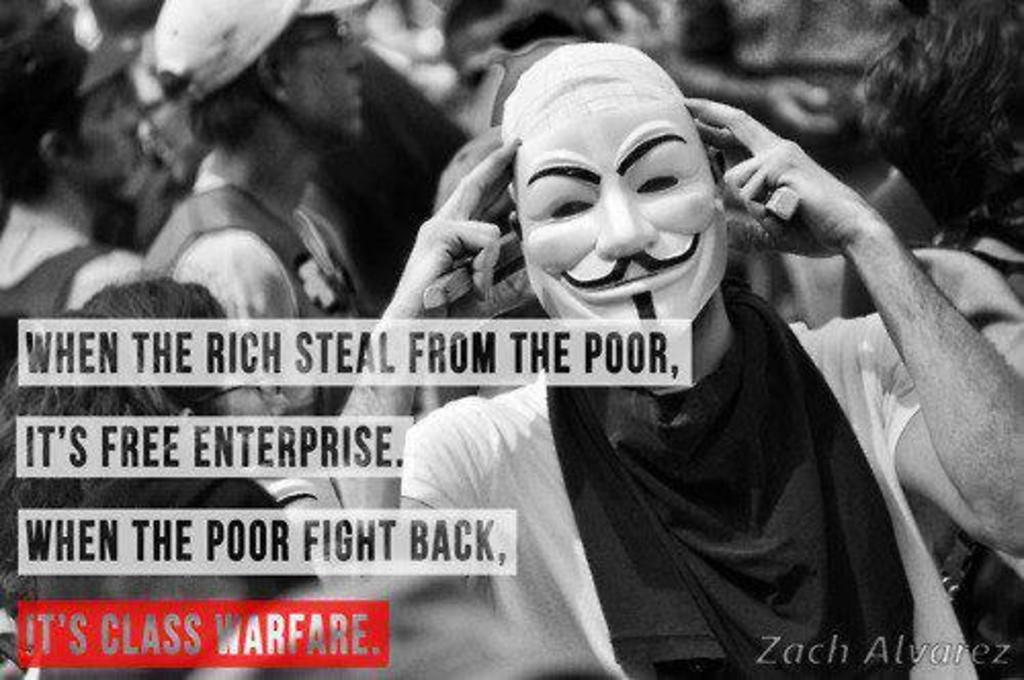What is the color scheme of the image? The image is black and white. What can be seen in the image besides the color scheme? There are people standing in the image. Is there any text present in the image? Yes, there is some text visible in the image. What type of horn can be seen in the hands of the people in the image? There is no horn present in the image; it is a black and white image with people standing and some text visible. 